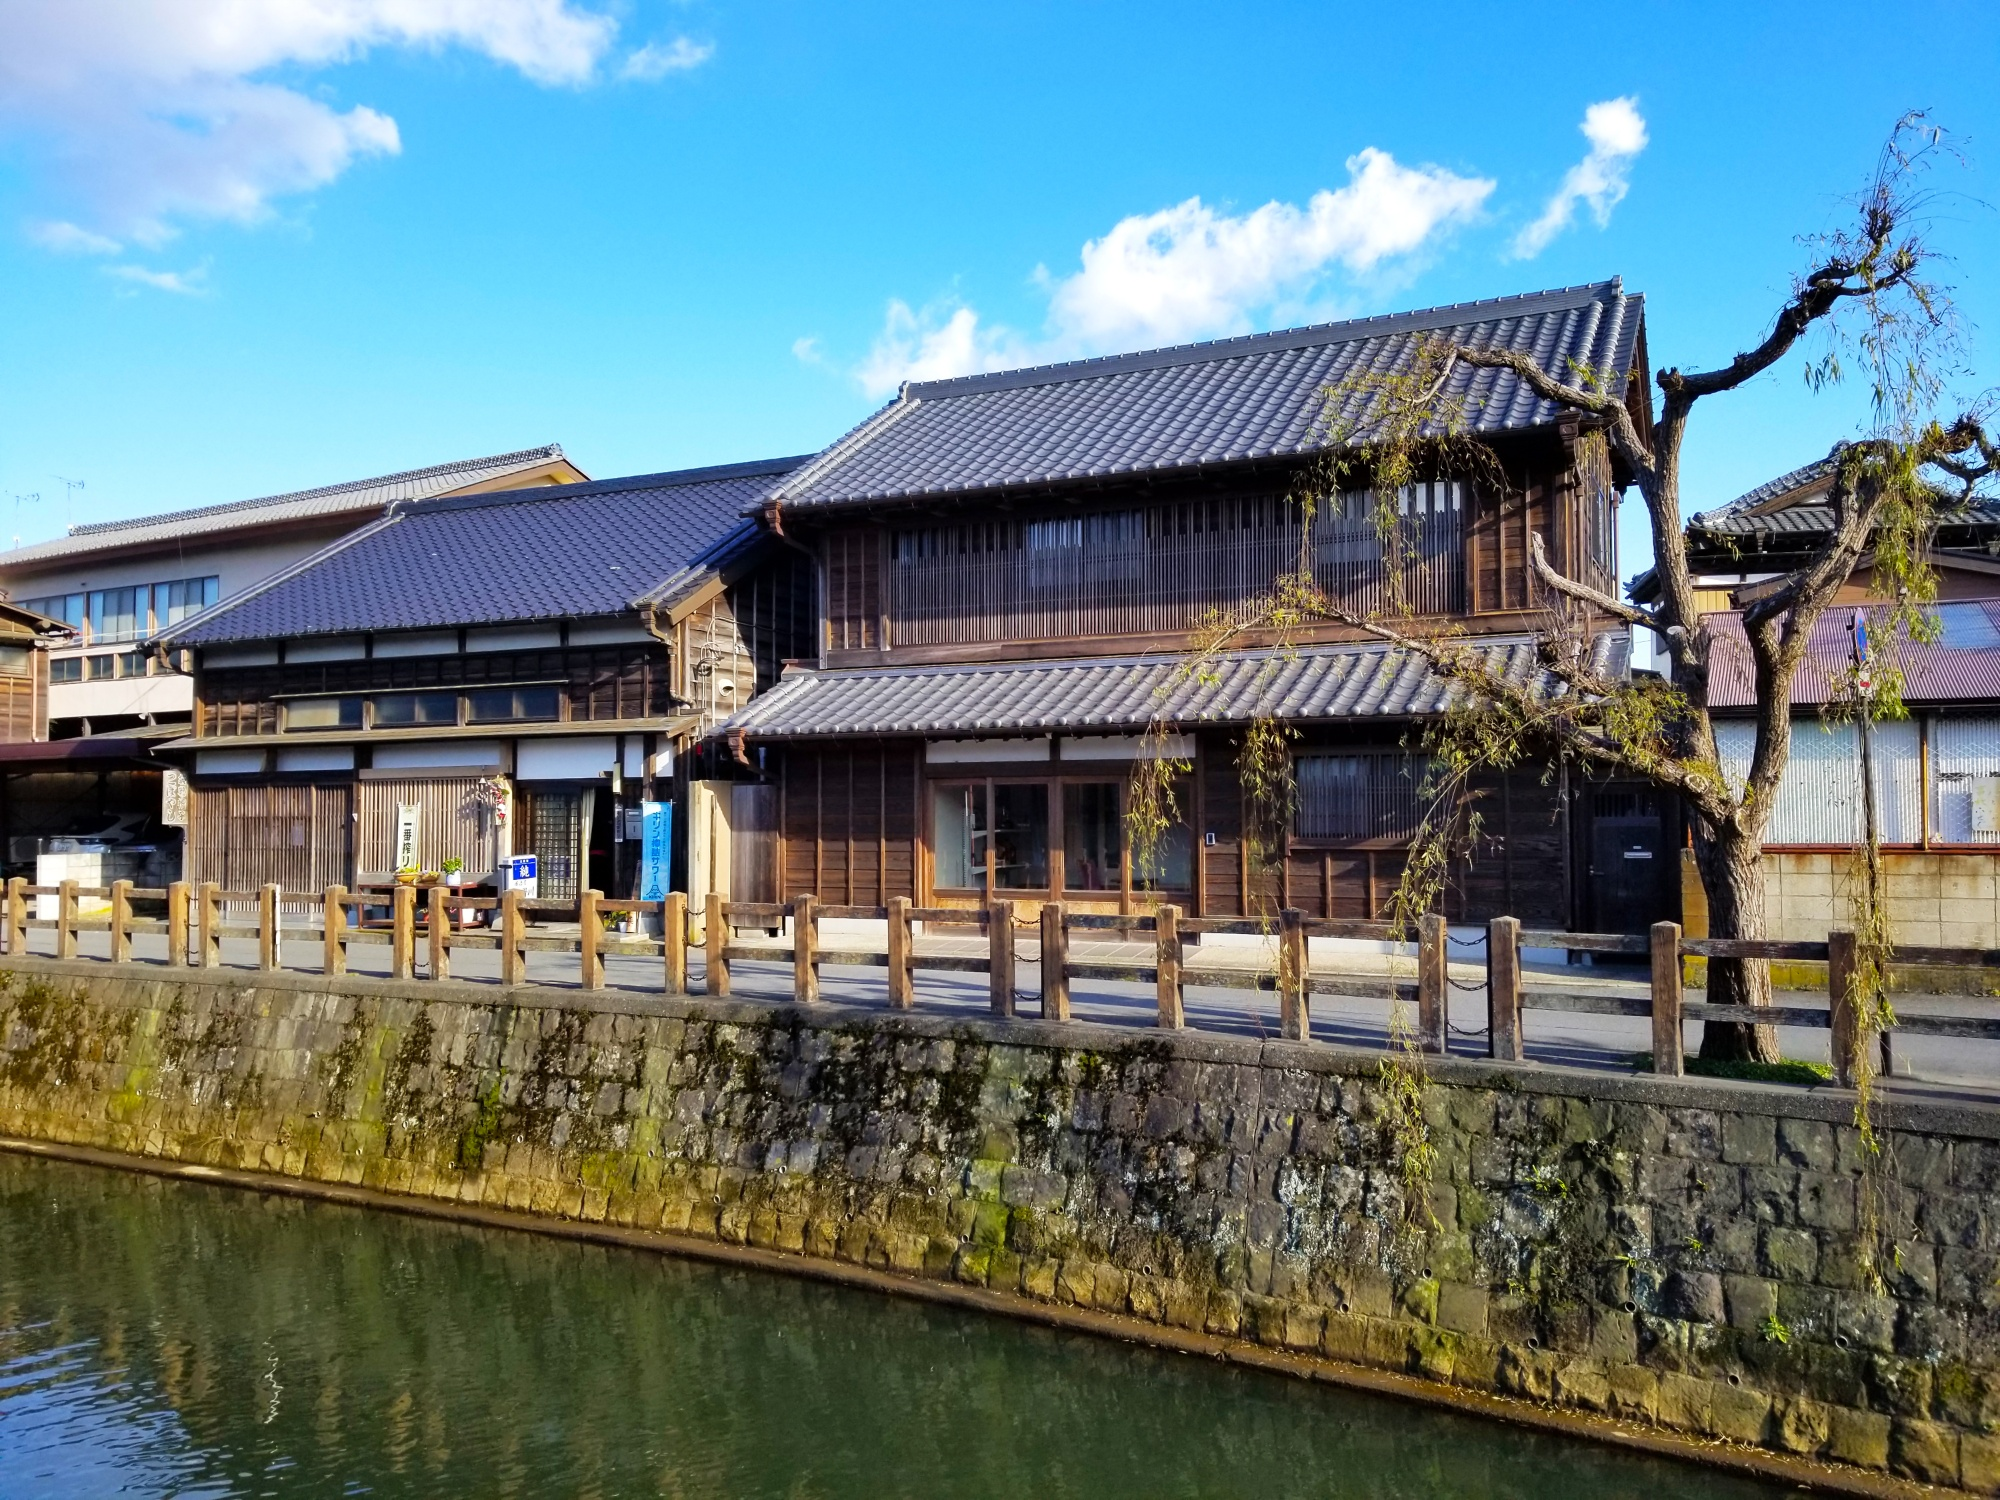Write a detailed description of the given image.
 The image captures a serene winter scene in Japan. A traditional Japanese building, with its characteristic wooden exterior and tiled roof, nestles on the bank of a tranquil river. A sturdy stone wall separates the building from the water, providing a sense of security and harmony with nature. The trees around the building stand bare, their leafless branches reaching out to the clear blue sky above, indicating that the season is winter. The perspective of the image is from across the river, offering a comprehensive view of the building and its surroundings. The calm water of the river mirrors the building and the sky, adding a touch of symmetry to the scene. The overall image paints a picture of tranquility and timeless beauty, characteristic of traditional Japanese landscapes. 